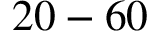Convert formula to latex. <formula><loc_0><loc_0><loc_500><loc_500>2 0 - 6 0</formula> 